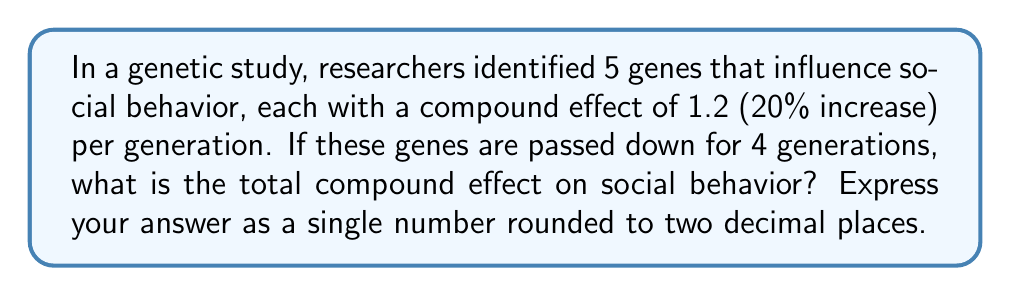Solve this math problem. To solve this problem, we need to use the compound effect formula and apply it to multiple genes over multiple generations. Let's break it down step-by-step:

1. The compound effect for each gene is 1.2 (20% increase).
2. We have 5 genes influencing social behavior.
3. The effects are compounded over 4 generations.

Let's use the exponent formula to calculate this:

$$ \text{Total Effect} = (1.2)^{5 \times 4} $$

Here's why:
- We raise 1.2 to the power of (5 × 4) because each of the 5 genes compounds 4 times (once per generation).

Now, let's calculate:

$$ \text{Total Effect} = (1.2)^{20} $$
$$ = 38.3376... $$

Rounding to two decimal places:

$$ \text{Total Effect} ≈ 38.34 $$

This means the combined effect of these 5 genes over 4 generations is approximately a 38.34-fold increase in the influenced social behavior.
Answer: 38.34 